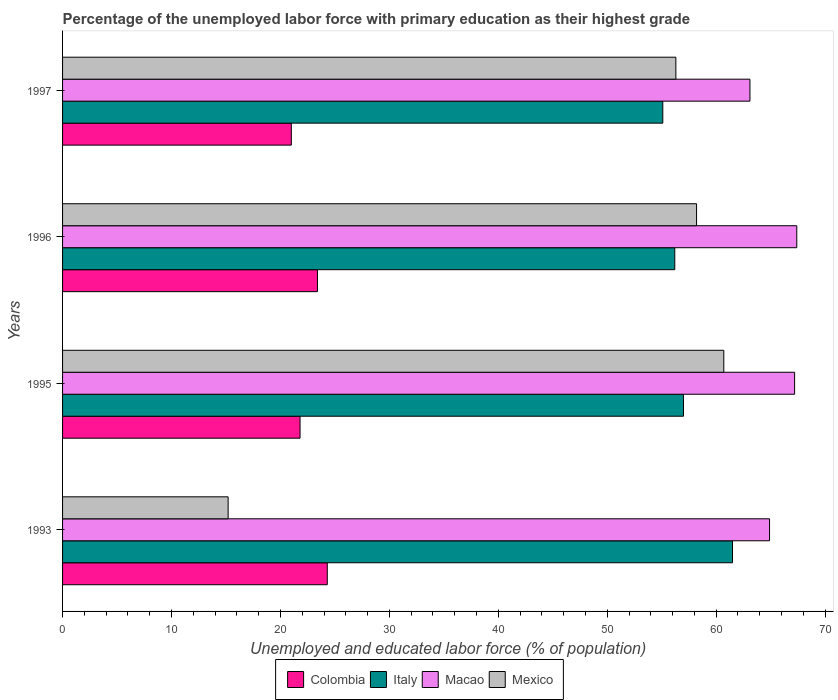How many different coloured bars are there?
Give a very brief answer. 4. How many bars are there on the 1st tick from the top?
Give a very brief answer. 4. What is the label of the 1st group of bars from the top?
Your answer should be very brief. 1997. What is the percentage of the unemployed labor force with primary education in Macao in 1996?
Offer a very short reply. 67.4. Across all years, what is the maximum percentage of the unemployed labor force with primary education in Macao?
Your answer should be very brief. 67.4. Across all years, what is the minimum percentage of the unemployed labor force with primary education in Mexico?
Offer a very short reply. 15.2. In which year was the percentage of the unemployed labor force with primary education in Italy minimum?
Provide a short and direct response. 1997. What is the total percentage of the unemployed labor force with primary education in Colombia in the graph?
Your response must be concise. 90.5. What is the difference between the percentage of the unemployed labor force with primary education in Macao in 1996 and that in 1997?
Ensure brevity in your answer.  4.3. What is the difference between the percentage of the unemployed labor force with primary education in Colombia in 1993 and the percentage of the unemployed labor force with primary education in Italy in 1995?
Provide a succinct answer. -32.7. What is the average percentage of the unemployed labor force with primary education in Italy per year?
Your answer should be compact. 57.45. In the year 1995, what is the difference between the percentage of the unemployed labor force with primary education in Italy and percentage of the unemployed labor force with primary education in Macao?
Your response must be concise. -10.2. What is the ratio of the percentage of the unemployed labor force with primary education in Macao in 1993 to that in 1996?
Your answer should be compact. 0.96. What is the difference between the highest and the lowest percentage of the unemployed labor force with primary education in Colombia?
Ensure brevity in your answer.  3.3. What does the 1st bar from the top in 1997 represents?
Offer a terse response. Mexico. What does the 2nd bar from the bottom in 1995 represents?
Ensure brevity in your answer.  Italy. Where does the legend appear in the graph?
Make the answer very short. Bottom center. How many legend labels are there?
Your answer should be very brief. 4. How are the legend labels stacked?
Keep it short and to the point. Horizontal. What is the title of the graph?
Provide a succinct answer. Percentage of the unemployed labor force with primary education as their highest grade. What is the label or title of the X-axis?
Give a very brief answer. Unemployed and educated labor force (% of population). What is the label or title of the Y-axis?
Give a very brief answer. Years. What is the Unemployed and educated labor force (% of population) of Colombia in 1993?
Provide a short and direct response. 24.3. What is the Unemployed and educated labor force (% of population) in Italy in 1993?
Your answer should be compact. 61.5. What is the Unemployed and educated labor force (% of population) in Macao in 1993?
Make the answer very short. 64.9. What is the Unemployed and educated labor force (% of population) in Mexico in 1993?
Ensure brevity in your answer.  15.2. What is the Unemployed and educated labor force (% of population) in Colombia in 1995?
Ensure brevity in your answer.  21.8. What is the Unemployed and educated labor force (% of population) in Macao in 1995?
Make the answer very short. 67.2. What is the Unemployed and educated labor force (% of population) of Mexico in 1995?
Offer a terse response. 60.7. What is the Unemployed and educated labor force (% of population) of Colombia in 1996?
Give a very brief answer. 23.4. What is the Unemployed and educated labor force (% of population) of Italy in 1996?
Ensure brevity in your answer.  56.2. What is the Unemployed and educated labor force (% of population) of Macao in 1996?
Your answer should be compact. 67.4. What is the Unemployed and educated labor force (% of population) in Mexico in 1996?
Keep it short and to the point. 58.2. What is the Unemployed and educated labor force (% of population) in Italy in 1997?
Offer a terse response. 55.1. What is the Unemployed and educated labor force (% of population) in Macao in 1997?
Provide a short and direct response. 63.1. What is the Unemployed and educated labor force (% of population) of Mexico in 1997?
Ensure brevity in your answer.  56.3. Across all years, what is the maximum Unemployed and educated labor force (% of population) of Colombia?
Your answer should be compact. 24.3. Across all years, what is the maximum Unemployed and educated labor force (% of population) of Italy?
Provide a short and direct response. 61.5. Across all years, what is the maximum Unemployed and educated labor force (% of population) in Macao?
Ensure brevity in your answer.  67.4. Across all years, what is the maximum Unemployed and educated labor force (% of population) in Mexico?
Provide a short and direct response. 60.7. Across all years, what is the minimum Unemployed and educated labor force (% of population) of Italy?
Make the answer very short. 55.1. Across all years, what is the minimum Unemployed and educated labor force (% of population) in Macao?
Keep it short and to the point. 63.1. Across all years, what is the minimum Unemployed and educated labor force (% of population) of Mexico?
Give a very brief answer. 15.2. What is the total Unemployed and educated labor force (% of population) of Colombia in the graph?
Offer a terse response. 90.5. What is the total Unemployed and educated labor force (% of population) in Italy in the graph?
Your response must be concise. 229.8. What is the total Unemployed and educated labor force (% of population) of Macao in the graph?
Offer a terse response. 262.6. What is the total Unemployed and educated labor force (% of population) of Mexico in the graph?
Offer a terse response. 190.4. What is the difference between the Unemployed and educated labor force (% of population) of Colombia in 1993 and that in 1995?
Keep it short and to the point. 2.5. What is the difference between the Unemployed and educated labor force (% of population) in Italy in 1993 and that in 1995?
Provide a short and direct response. 4.5. What is the difference between the Unemployed and educated labor force (% of population) in Macao in 1993 and that in 1995?
Your answer should be compact. -2.3. What is the difference between the Unemployed and educated labor force (% of population) of Mexico in 1993 and that in 1995?
Provide a succinct answer. -45.5. What is the difference between the Unemployed and educated labor force (% of population) in Colombia in 1993 and that in 1996?
Ensure brevity in your answer.  0.9. What is the difference between the Unemployed and educated labor force (% of population) of Italy in 1993 and that in 1996?
Offer a very short reply. 5.3. What is the difference between the Unemployed and educated labor force (% of population) of Mexico in 1993 and that in 1996?
Make the answer very short. -43. What is the difference between the Unemployed and educated labor force (% of population) in Colombia in 1993 and that in 1997?
Keep it short and to the point. 3.3. What is the difference between the Unemployed and educated labor force (% of population) of Macao in 1993 and that in 1997?
Offer a very short reply. 1.8. What is the difference between the Unemployed and educated labor force (% of population) of Mexico in 1993 and that in 1997?
Offer a very short reply. -41.1. What is the difference between the Unemployed and educated labor force (% of population) of Colombia in 1995 and that in 1996?
Ensure brevity in your answer.  -1.6. What is the difference between the Unemployed and educated labor force (% of population) of Italy in 1995 and that in 1996?
Provide a short and direct response. 0.8. What is the difference between the Unemployed and educated labor force (% of population) of Macao in 1995 and that in 1996?
Your response must be concise. -0.2. What is the difference between the Unemployed and educated labor force (% of population) in Italy in 1995 and that in 1997?
Make the answer very short. 1.9. What is the difference between the Unemployed and educated labor force (% of population) of Mexico in 1995 and that in 1997?
Offer a very short reply. 4.4. What is the difference between the Unemployed and educated labor force (% of population) in Italy in 1996 and that in 1997?
Offer a very short reply. 1.1. What is the difference between the Unemployed and educated labor force (% of population) in Macao in 1996 and that in 1997?
Your response must be concise. 4.3. What is the difference between the Unemployed and educated labor force (% of population) in Colombia in 1993 and the Unemployed and educated labor force (% of population) in Italy in 1995?
Provide a succinct answer. -32.7. What is the difference between the Unemployed and educated labor force (% of population) of Colombia in 1993 and the Unemployed and educated labor force (% of population) of Macao in 1995?
Your response must be concise. -42.9. What is the difference between the Unemployed and educated labor force (% of population) in Colombia in 1993 and the Unemployed and educated labor force (% of population) in Mexico in 1995?
Provide a succinct answer. -36.4. What is the difference between the Unemployed and educated labor force (% of population) of Italy in 1993 and the Unemployed and educated labor force (% of population) of Macao in 1995?
Provide a short and direct response. -5.7. What is the difference between the Unemployed and educated labor force (% of population) of Macao in 1993 and the Unemployed and educated labor force (% of population) of Mexico in 1995?
Ensure brevity in your answer.  4.2. What is the difference between the Unemployed and educated labor force (% of population) in Colombia in 1993 and the Unemployed and educated labor force (% of population) in Italy in 1996?
Give a very brief answer. -31.9. What is the difference between the Unemployed and educated labor force (% of population) in Colombia in 1993 and the Unemployed and educated labor force (% of population) in Macao in 1996?
Provide a short and direct response. -43.1. What is the difference between the Unemployed and educated labor force (% of population) of Colombia in 1993 and the Unemployed and educated labor force (% of population) of Mexico in 1996?
Offer a terse response. -33.9. What is the difference between the Unemployed and educated labor force (% of population) in Italy in 1993 and the Unemployed and educated labor force (% of population) in Macao in 1996?
Make the answer very short. -5.9. What is the difference between the Unemployed and educated labor force (% of population) of Colombia in 1993 and the Unemployed and educated labor force (% of population) of Italy in 1997?
Give a very brief answer. -30.8. What is the difference between the Unemployed and educated labor force (% of population) in Colombia in 1993 and the Unemployed and educated labor force (% of population) in Macao in 1997?
Offer a very short reply. -38.8. What is the difference between the Unemployed and educated labor force (% of population) in Colombia in 1993 and the Unemployed and educated labor force (% of population) in Mexico in 1997?
Keep it short and to the point. -32. What is the difference between the Unemployed and educated labor force (% of population) in Colombia in 1995 and the Unemployed and educated labor force (% of population) in Italy in 1996?
Offer a terse response. -34.4. What is the difference between the Unemployed and educated labor force (% of population) of Colombia in 1995 and the Unemployed and educated labor force (% of population) of Macao in 1996?
Your answer should be compact. -45.6. What is the difference between the Unemployed and educated labor force (% of population) of Colombia in 1995 and the Unemployed and educated labor force (% of population) of Mexico in 1996?
Provide a succinct answer. -36.4. What is the difference between the Unemployed and educated labor force (% of population) in Italy in 1995 and the Unemployed and educated labor force (% of population) in Mexico in 1996?
Offer a terse response. -1.2. What is the difference between the Unemployed and educated labor force (% of population) in Macao in 1995 and the Unemployed and educated labor force (% of population) in Mexico in 1996?
Your response must be concise. 9. What is the difference between the Unemployed and educated labor force (% of population) of Colombia in 1995 and the Unemployed and educated labor force (% of population) of Italy in 1997?
Your response must be concise. -33.3. What is the difference between the Unemployed and educated labor force (% of population) in Colombia in 1995 and the Unemployed and educated labor force (% of population) in Macao in 1997?
Keep it short and to the point. -41.3. What is the difference between the Unemployed and educated labor force (% of population) of Colombia in 1995 and the Unemployed and educated labor force (% of population) of Mexico in 1997?
Your answer should be compact. -34.5. What is the difference between the Unemployed and educated labor force (% of population) of Colombia in 1996 and the Unemployed and educated labor force (% of population) of Italy in 1997?
Provide a short and direct response. -31.7. What is the difference between the Unemployed and educated labor force (% of population) in Colombia in 1996 and the Unemployed and educated labor force (% of population) in Macao in 1997?
Offer a terse response. -39.7. What is the difference between the Unemployed and educated labor force (% of population) in Colombia in 1996 and the Unemployed and educated labor force (% of population) in Mexico in 1997?
Make the answer very short. -32.9. What is the difference between the Unemployed and educated labor force (% of population) in Italy in 1996 and the Unemployed and educated labor force (% of population) in Mexico in 1997?
Provide a succinct answer. -0.1. What is the difference between the Unemployed and educated labor force (% of population) of Macao in 1996 and the Unemployed and educated labor force (% of population) of Mexico in 1997?
Make the answer very short. 11.1. What is the average Unemployed and educated labor force (% of population) in Colombia per year?
Offer a terse response. 22.62. What is the average Unemployed and educated labor force (% of population) in Italy per year?
Provide a succinct answer. 57.45. What is the average Unemployed and educated labor force (% of population) of Macao per year?
Offer a very short reply. 65.65. What is the average Unemployed and educated labor force (% of population) of Mexico per year?
Your response must be concise. 47.6. In the year 1993, what is the difference between the Unemployed and educated labor force (% of population) of Colombia and Unemployed and educated labor force (% of population) of Italy?
Your answer should be very brief. -37.2. In the year 1993, what is the difference between the Unemployed and educated labor force (% of population) in Colombia and Unemployed and educated labor force (% of population) in Macao?
Provide a short and direct response. -40.6. In the year 1993, what is the difference between the Unemployed and educated labor force (% of population) of Colombia and Unemployed and educated labor force (% of population) of Mexico?
Provide a succinct answer. 9.1. In the year 1993, what is the difference between the Unemployed and educated labor force (% of population) in Italy and Unemployed and educated labor force (% of population) in Mexico?
Keep it short and to the point. 46.3. In the year 1993, what is the difference between the Unemployed and educated labor force (% of population) of Macao and Unemployed and educated labor force (% of population) of Mexico?
Your response must be concise. 49.7. In the year 1995, what is the difference between the Unemployed and educated labor force (% of population) in Colombia and Unemployed and educated labor force (% of population) in Italy?
Keep it short and to the point. -35.2. In the year 1995, what is the difference between the Unemployed and educated labor force (% of population) in Colombia and Unemployed and educated labor force (% of population) in Macao?
Your response must be concise. -45.4. In the year 1995, what is the difference between the Unemployed and educated labor force (% of population) in Colombia and Unemployed and educated labor force (% of population) in Mexico?
Keep it short and to the point. -38.9. In the year 1995, what is the difference between the Unemployed and educated labor force (% of population) of Italy and Unemployed and educated labor force (% of population) of Macao?
Your answer should be compact. -10.2. In the year 1995, what is the difference between the Unemployed and educated labor force (% of population) of Italy and Unemployed and educated labor force (% of population) of Mexico?
Ensure brevity in your answer.  -3.7. In the year 1995, what is the difference between the Unemployed and educated labor force (% of population) in Macao and Unemployed and educated labor force (% of population) in Mexico?
Your answer should be compact. 6.5. In the year 1996, what is the difference between the Unemployed and educated labor force (% of population) of Colombia and Unemployed and educated labor force (% of population) of Italy?
Keep it short and to the point. -32.8. In the year 1996, what is the difference between the Unemployed and educated labor force (% of population) of Colombia and Unemployed and educated labor force (% of population) of Macao?
Provide a succinct answer. -44. In the year 1996, what is the difference between the Unemployed and educated labor force (% of population) of Colombia and Unemployed and educated labor force (% of population) of Mexico?
Offer a terse response. -34.8. In the year 1996, what is the difference between the Unemployed and educated labor force (% of population) in Italy and Unemployed and educated labor force (% of population) in Mexico?
Your response must be concise. -2. In the year 1997, what is the difference between the Unemployed and educated labor force (% of population) of Colombia and Unemployed and educated labor force (% of population) of Italy?
Provide a succinct answer. -34.1. In the year 1997, what is the difference between the Unemployed and educated labor force (% of population) of Colombia and Unemployed and educated labor force (% of population) of Macao?
Your response must be concise. -42.1. In the year 1997, what is the difference between the Unemployed and educated labor force (% of population) in Colombia and Unemployed and educated labor force (% of population) in Mexico?
Ensure brevity in your answer.  -35.3. What is the ratio of the Unemployed and educated labor force (% of population) of Colombia in 1993 to that in 1995?
Your response must be concise. 1.11. What is the ratio of the Unemployed and educated labor force (% of population) in Italy in 1993 to that in 1995?
Offer a very short reply. 1.08. What is the ratio of the Unemployed and educated labor force (% of population) in Macao in 1993 to that in 1995?
Provide a short and direct response. 0.97. What is the ratio of the Unemployed and educated labor force (% of population) in Mexico in 1993 to that in 1995?
Give a very brief answer. 0.25. What is the ratio of the Unemployed and educated labor force (% of population) in Colombia in 1993 to that in 1996?
Provide a succinct answer. 1.04. What is the ratio of the Unemployed and educated labor force (% of population) in Italy in 1993 to that in 1996?
Provide a succinct answer. 1.09. What is the ratio of the Unemployed and educated labor force (% of population) of Macao in 1993 to that in 1996?
Your response must be concise. 0.96. What is the ratio of the Unemployed and educated labor force (% of population) of Mexico in 1993 to that in 1996?
Make the answer very short. 0.26. What is the ratio of the Unemployed and educated labor force (% of population) of Colombia in 1993 to that in 1997?
Give a very brief answer. 1.16. What is the ratio of the Unemployed and educated labor force (% of population) of Italy in 1993 to that in 1997?
Provide a short and direct response. 1.12. What is the ratio of the Unemployed and educated labor force (% of population) of Macao in 1993 to that in 1997?
Make the answer very short. 1.03. What is the ratio of the Unemployed and educated labor force (% of population) of Mexico in 1993 to that in 1997?
Offer a very short reply. 0.27. What is the ratio of the Unemployed and educated labor force (% of population) of Colombia in 1995 to that in 1996?
Make the answer very short. 0.93. What is the ratio of the Unemployed and educated labor force (% of population) of Italy in 1995 to that in 1996?
Ensure brevity in your answer.  1.01. What is the ratio of the Unemployed and educated labor force (% of population) in Macao in 1995 to that in 1996?
Provide a succinct answer. 1. What is the ratio of the Unemployed and educated labor force (% of population) of Mexico in 1995 to that in 1996?
Your answer should be very brief. 1.04. What is the ratio of the Unemployed and educated labor force (% of population) in Colombia in 1995 to that in 1997?
Your answer should be compact. 1.04. What is the ratio of the Unemployed and educated labor force (% of population) in Italy in 1995 to that in 1997?
Ensure brevity in your answer.  1.03. What is the ratio of the Unemployed and educated labor force (% of population) of Macao in 1995 to that in 1997?
Give a very brief answer. 1.06. What is the ratio of the Unemployed and educated labor force (% of population) in Mexico in 1995 to that in 1997?
Your answer should be very brief. 1.08. What is the ratio of the Unemployed and educated labor force (% of population) of Colombia in 1996 to that in 1997?
Ensure brevity in your answer.  1.11. What is the ratio of the Unemployed and educated labor force (% of population) in Macao in 1996 to that in 1997?
Provide a succinct answer. 1.07. What is the ratio of the Unemployed and educated labor force (% of population) of Mexico in 1996 to that in 1997?
Your answer should be very brief. 1.03. What is the difference between the highest and the second highest Unemployed and educated labor force (% of population) of Italy?
Your answer should be very brief. 4.5. What is the difference between the highest and the lowest Unemployed and educated labor force (% of population) in Macao?
Your response must be concise. 4.3. What is the difference between the highest and the lowest Unemployed and educated labor force (% of population) of Mexico?
Make the answer very short. 45.5. 